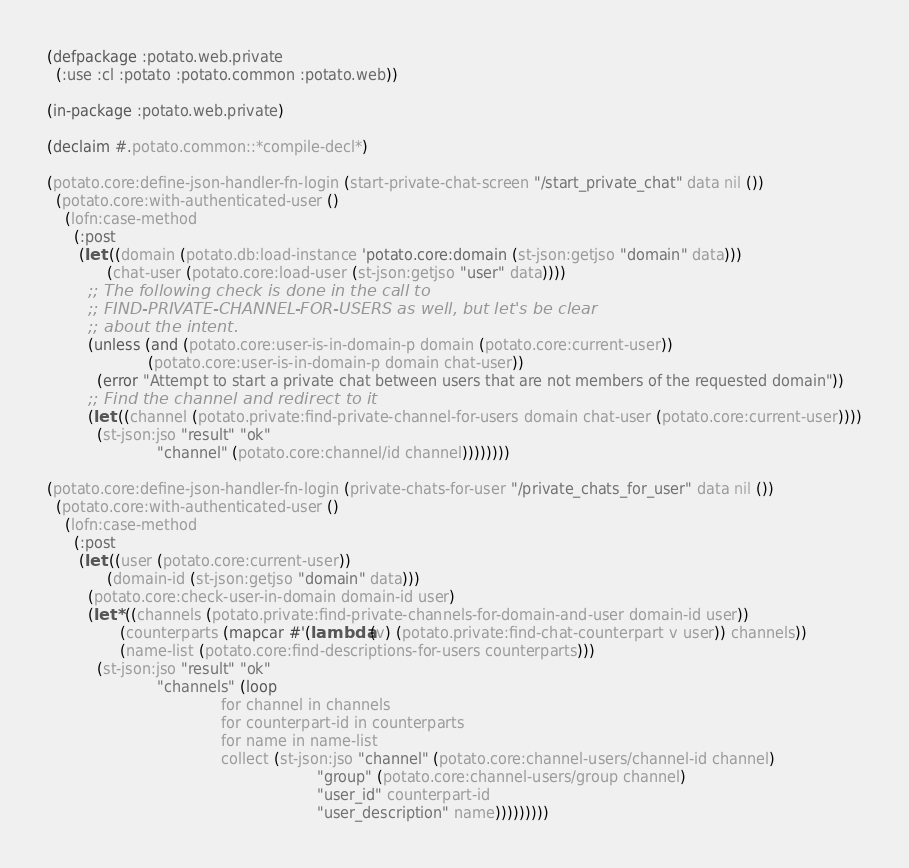<code> <loc_0><loc_0><loc_500><loc_500><_Lisp_>(defpackage :potato.web.private
  (:use :cl :potato :potato.common :potato.web))

(in-package :potato.web.private)

(declaim #.potato.common::*compile-decl*)

(potato.core:define-json-handler-fn-login (start-private-chat-screen "/start_private_chat" data nil ())
  (potato.core:with-authenticated-user ()
    (lofn:case-method
      (:post
       (let ((domain (potato.db:load-instance 'potato.core:domain (st-json:getjso "domain" data)))
             (chat-user (potato.core:load-user (st-json:getjso "user" data))))
         ;; The following check is done in the call to
         ;; FIND-PRIVATE-CHANNEL-FOR-USERS as well, but let's be clear
         ;; about the intent.
         (unless (and (potato.core:user-is-in-domain-p domain (potato.core:current-user))
                      (potato.core:user-is-in-domain-p domain chat-user))
           (error "Attempt to start a private chat between users that are not members of the requested domain"))
         ;; Find the channel and redirect to it
         (let ((channel (potato.private:find-private-channel-for-users domain chat-user (potato.core:current-user))))
           (st-json:jso "result" "ok"
                        "channel" (potato.core:channel/id channel))))))))

(potato.core:define-json-handler-fn-login (private-chats-for-user "/private_chats_for_user" data nil ())
  (potato.core:with-authenticated-user ()
    (lofn:case-method
      (:post
       (let ((user (potato.core:current-user))
             (domain-id (st-json:getjso "domain" data)))
         (potato.core:check-user-in-domain domain-id user)
         (let* ((channels (potato.private:find-private-channels-for-domain-and-user domain-id user))
                (counterparts (mapcar #'(lambda (v) (potato.private:find-chat-counterpart v user)) channels))
                (name-list (potato.core:find-descriptions-for-users counterparts)))
           (st-json:jso "result" "ok"
                        "channels" (loop
                                      for channel in channels
                                      for counterpart-id in counterparts
                                      for name in name-list
                                      collect (st-json:jso "channel" (potato.core:channel-users/channel-id channel)
                                                           "group" (potato.core:channel-users/group channel)
                                                           "user_id" counterpart-id
                                                           "user_description" name)))))))))
</code> 